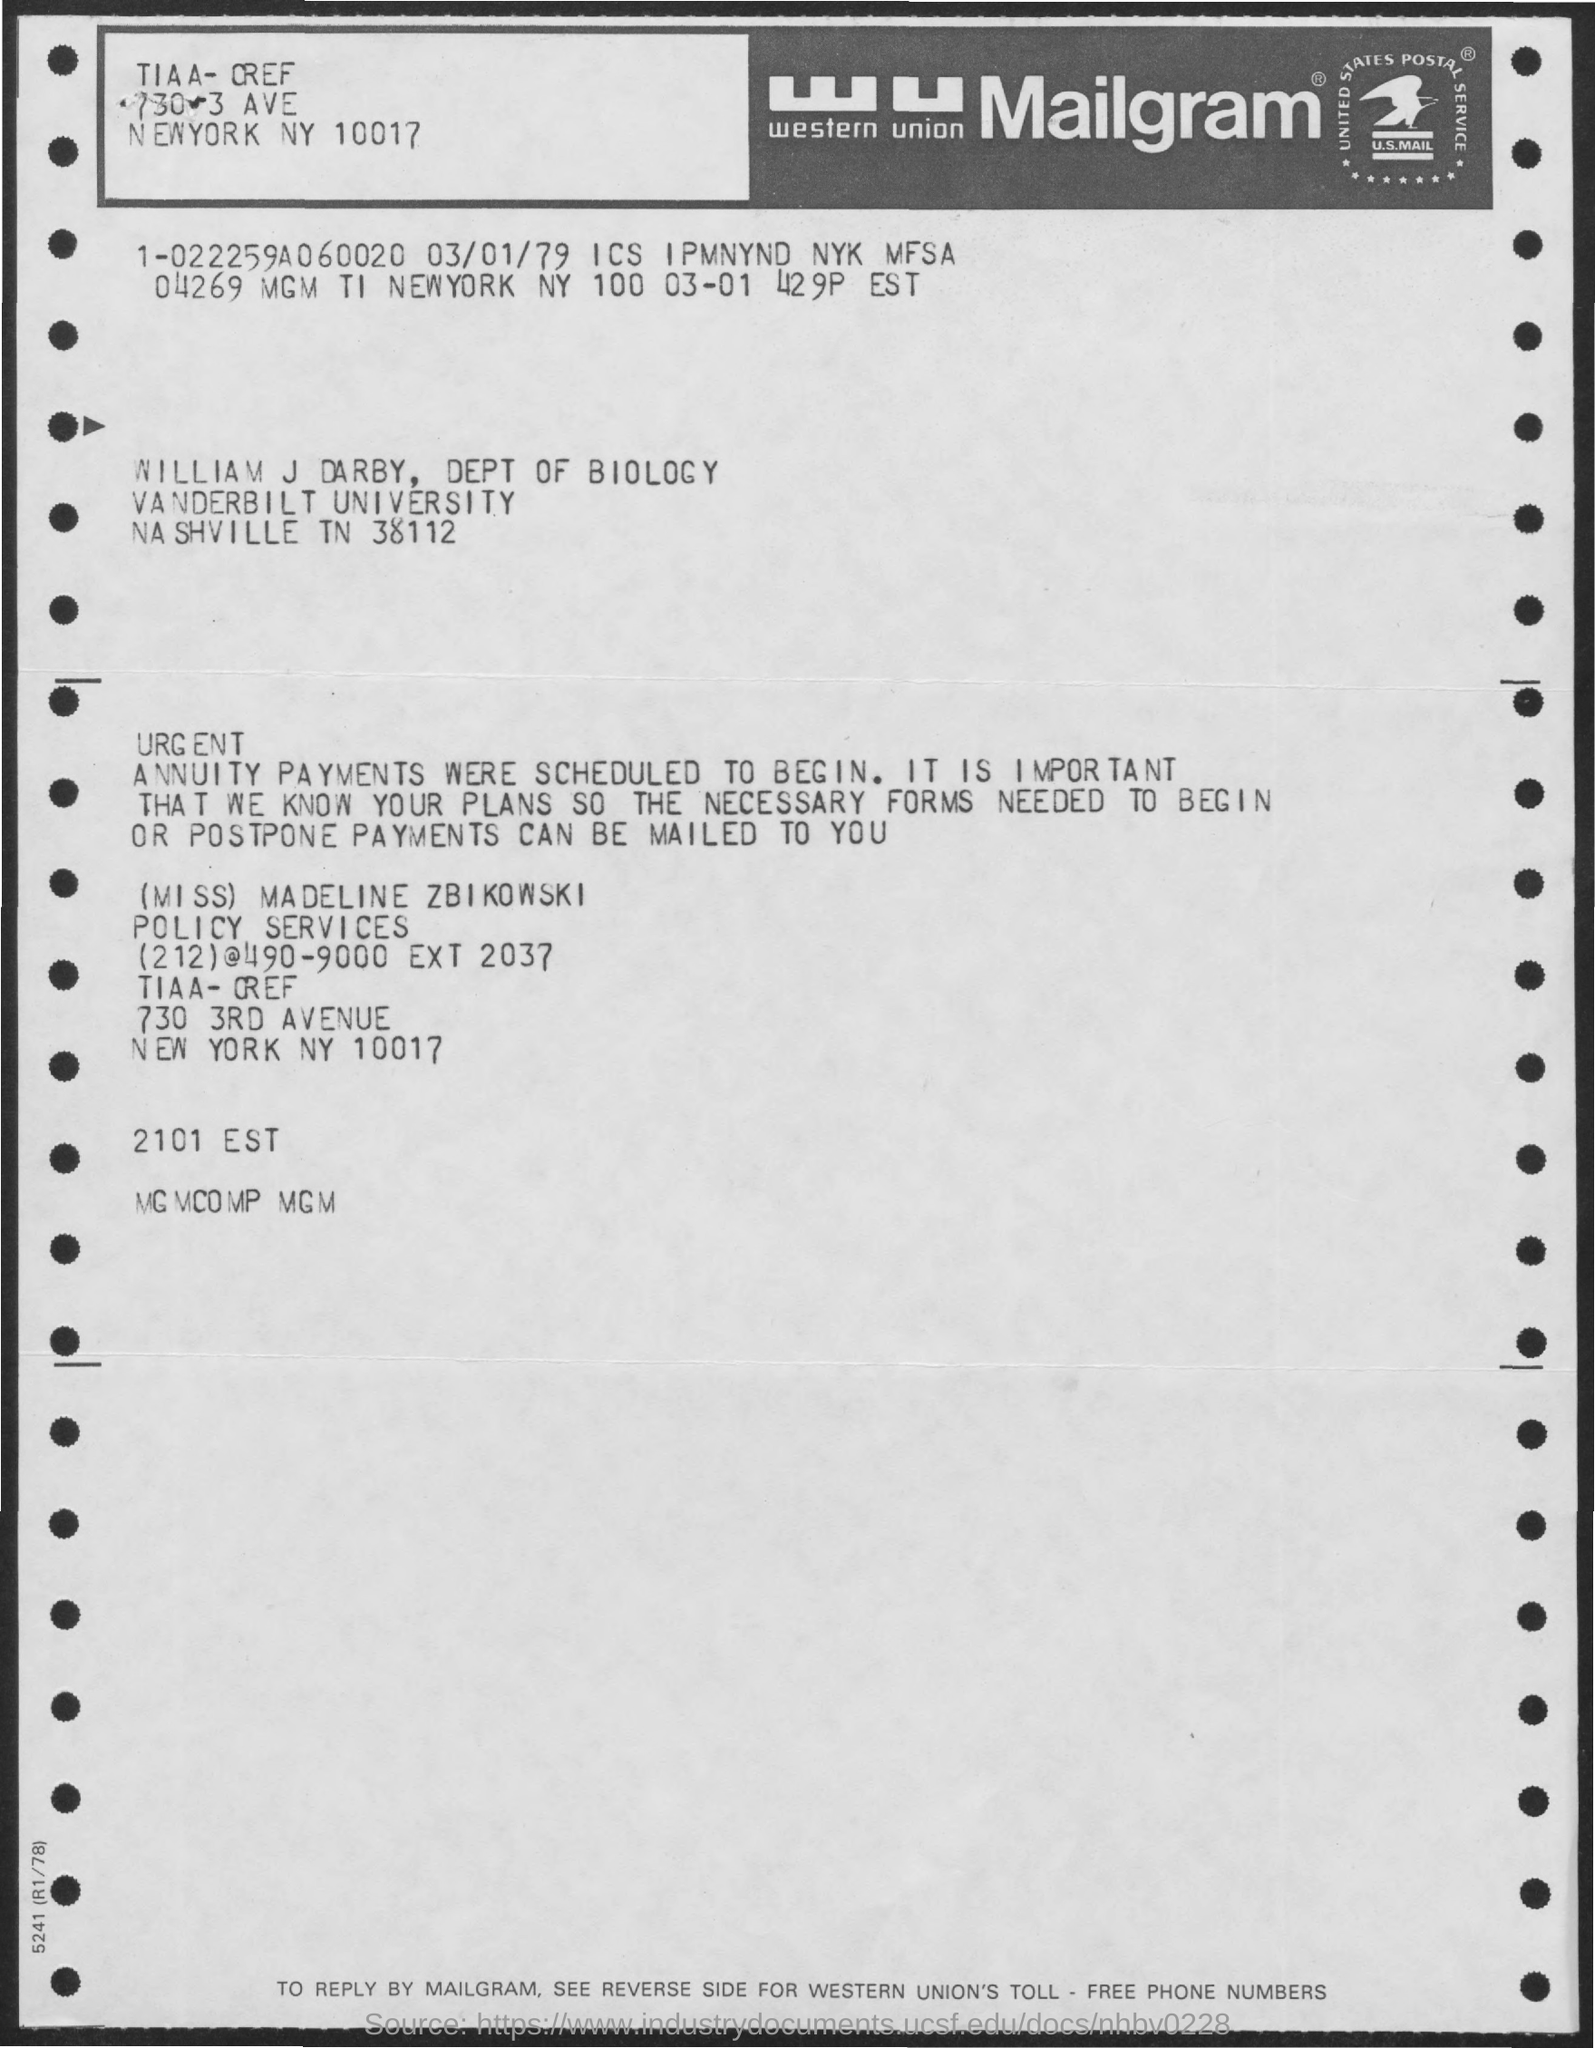To Whom is this letter addressed to?
Your response must be concise. William J Darby. Who is this letter from?
Your response must be concise. (Miss) Madeline Zbikowski. 